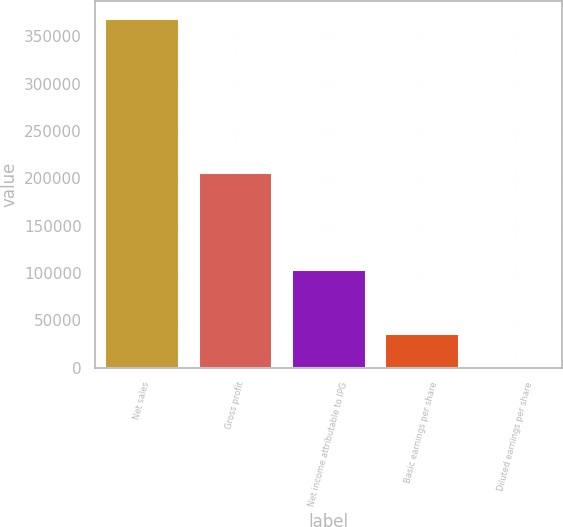<chart> <loc_0><loc_0><loc_500><loc_500><bar_chart><fcel>Net sales<fcel>Gross profit<fcel>Net income attributable to IPG<fcel>Basic earnings per share<fcel>Diluted earnings per share<nl><fcel>369373<fcel>206296<fcel>104116<fcel>36939<fcel>1.91<nl></chart> 